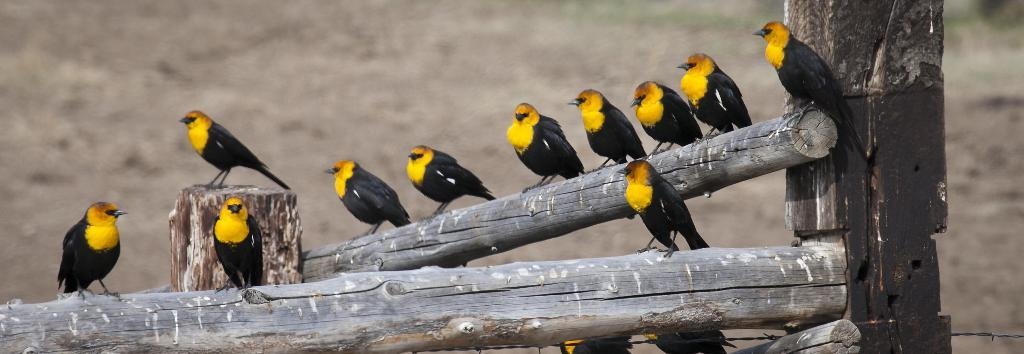What type of animals can be seen in the image? There is a group of birds in the image. What are the birds standing on? The birds are standing on wooden logs. Can you describe the background of the image? The background of the image is blurred. What type of ink is being used by the deer in the image? There are no deer present in the image, and therefore no ink usage can be observed. 